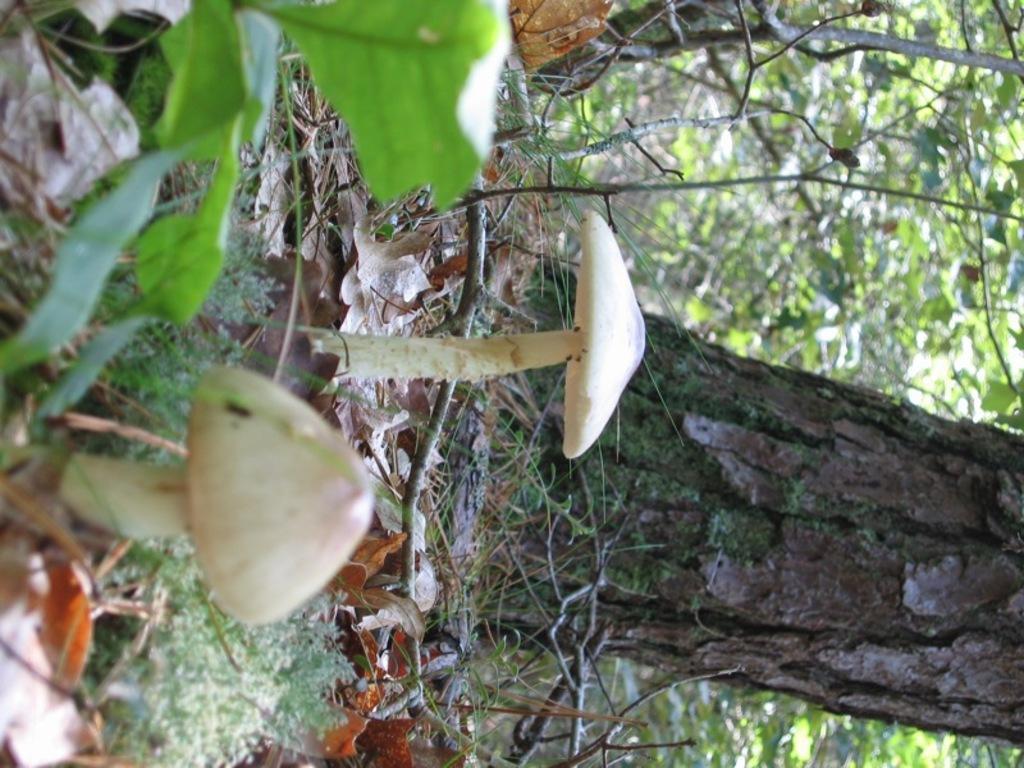In one or two sentences, can you explain what this image depicts? This picture shows couple of mushrooms on the ground and we see trees and a plant and few dry leaves on the ground. 